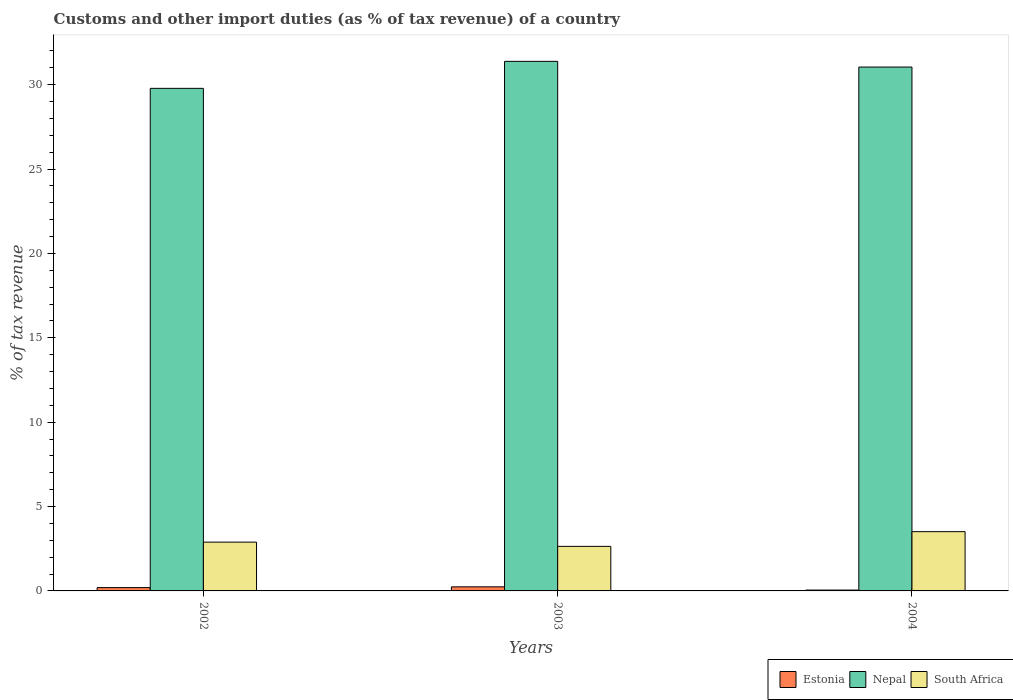How many different coloured bars are there?
Offer a very short reply. 3. How many groups of bars are there?
Offer a terse response. 3. Are the number of bars per tick equal to the number of legend labels?
Offer a terse response. Yes. How many bars are there on the 3rd tick from the left?
Your answer should be very brief. 3. How many bars are there on the 2nd tick from the right?
Keep it short and to the point. 3. What is the label of the 3rd group of bars from the left?
Provide a succinct answer. 2004. What is the percentage of tax revenue from customs in Estonia in 2003?
Make the answer very short. 0.24. Across all years, what is the maximum percentage of tax revenue from customs in Nepal?
Make the answer very short. 31.38. Across all years, what is the minimum percentage of tax revenue from customs in Nepal?
Provide a short and direct response. 29.78. In which year was the percentage of tax revenue from customs in Nepal maximum?
Your response must be concise. 2003. What is the total percentage of tax revenue from customs in Nepal in the graph?
Give a very brief answer. 92.2. What is the difference between the percentage of tax revenue from customs in Estonia in 2002 and that in 2004?
Keep it short and to the point. 0.15. What is the difference between the percentage of tax revenue from customs in Nepal in 2003 and the percentage of tax revenue from customs in Estonia in 2002?
Provide a succinct answer. 31.18. What is the average percentage of tax revenue from customs in Nepal per year?
Keep it short and to the point. 30.73. In the year 2002, what is the difference between the percentage of tax revenue from customs in Nepal and percentage of tax revenue from customs in South Africa?
Give a very brief answer. 26.89. What is the ratio of the percentage of tax revenue from customs in Nepal in 2002 to that in 2004?
Provide a succinct answer. 0.96. Is the difference between the percentage of tax revenue from customs in Nepal in 2002 and 2004 greater than the difference between the percentage of tax revenue from customs in South Africa in 2002 and 2004?
Give a very brief answer. No. What is the difference between the highest and the second highest percentage of tax revenue from customs in Estonia?
Your answer should be very brief. 0.05. What is the difference between the highest and the lowest percentage of tax revenue from customs in Nepal?
Offer a very short reply. 1.6. Is the sum of the percentage of tax revenue from customs in South Africa in 2002 and 2004 greater than the maximum percentage of tax revenue from customs in Estonia across all years?
Provide a short and direct response. Yes. What does the 3rd bar from the left in 2004 represents?
Provide a short and direct response. South Africa. What does the 1st bar from the right in 2002 represents?
Make the answer very short. South Africa. What is the difference between two consecutive major ticks on the Y-axis?
Your answer should be compact. 5. Are the values on the major ticks of Y-axis written in scientific E-notation?
Your answer should be compact. No. Does the graph contain any zero values?
Your answer should be compact. No. Where does the legend appear in the graph?
Give a very brief answer. Bottom right. How many legend labels are there?
Ensure brevity in your answer.  3. What is the title of the graph?
Provide a short and direct response. Customs and other import duties (as % of tax revenue) of a country. What is the label or title of the X-axis?
Give a very brief answer. Years. What is the label or title of the Y-axis?
Make the answer very short. % of tax revenue. What is the % of tax revenue of Estonia in 2002?
Make the answer very short. 0.2. What is the % of tax revenue of Nepal in 2002?
Give a very brief answer. 29.78. What is the % of tax revenue of South Africa in 2002?
Ensure brevity in your answer.  2.89. What is the % of tax revenue in Estonia in 2003?
Offer a terse response. 0.24. What is the % of tax revenue in Nepal in 2003?
Ensure brevity in your answer.  31.38. What is the % of tax revenue of South Africa in 2003?
Give a very brief answer. 2.64. What is the % of tax revenue of Estonia in 2004?
Offer a very short reply. 0.05. What is the % of tax revenue in Nepal in 2004?
Make the answer very short. 31.04. What is the % of tax revenue of South Africa in 2004?
Offer a very short reply. 3.51. Across all years, what is the maximum % of tax revenue in Estonia?
Offer a very short reply. 0.24. Across all years, what is the maximum % of tax revenue in Nepal?
Your response must be concise. 31.38. Across all years, what is the maximum % of tax revenue of South Africa?
Offer a terse response. 3.51. Across all years, what is the minimum % of tax revenue in Estonia?
Your answer should be compact. 0.05. Across all years, what is the minimum % of tax revenue in Nepal?
Make the answer very short. 29.78. Across all years, what is the minimum % of tax revenue of South Africa?
Keep it short and to the point. 2.64. What is the total % of tax revenue in Estonia in the graph?
Give a very brief answer. 0.49. What is the total % of tax revenue of Nepal in the graph?
Make the answer very short. 92.2. What is the total % of tax revenue in South Africa in the graph?
Give a very brief answer. 9.04. What is the difference between the % of tax revenue of Estonia in 2002 and that in 2003?
Provide a succinct answer. -0.04. What is the difference between the % of tax revenue in Nepal in 2002 and that in 2003?
Your response must be concise. -1.6. What is the difference between the % of tax revenue of South Africa in 2002 and that in 2003?
Make the answer very short. 0.25. What is the difference between the % of tax revenue in Estonia in 2002 and that in 2004?
Ensure brevity in your answer.  0.15. What is the difference between the % of tax revenue of Nepal in 2002 and that in 2004?
Give a very brief answer. -1.26. What is the difference between the % of tax revenue in South Africa in 2002 and that in 2004?
Your answer should be very brief. -0.62. What is the difference between the % of tax revenue in Estonia in 2003 and that in 2004?
Provide a short and direct response. 0.19. What is the difference between the % of tax revenue in Nepal in 2003 and that in 2004?
Offer a terse response. 0.34. What is the difference between the % of tax revenue in South Africa in 2003 and that in 2004?
Keep it short and to the point. -0.87. What is the difference between the % of tax revenue of Estonia in 2002 and the % of tax revenue of Nepal in 2003?
Your response must be concise. -31.18. What is the difference between the % of tax revenue of Estonia in 2002 and the % of tax revenue of South Africa in 2003?
Keep it short and to the point. -2.44. What is the difference between the % of tax revenue of Nepal in 2002 and the % of tax revenue of South Africa in 2003?
Ensure brevity in your answer.  27.14. What is the difference between the % of tax revenue of Estonia in 2002 and the % of tax revenue of Nepal in 2004?
Offer a very short reply. -30.85. What is the difference between the % of tax revenue of Estonia in 2002 and the % of tax revenue of South Africa in 2004?
Your response must be concise. -3.31. What is the difference between the % of tax revenue in Nepal in 2002 and the % of tax revenue in South Africa in 2004?
Provide a succinct answer. 26.27. What is the difference between the % of tax revenue in Estonia in 2003 and the % of tax revenue in Nepal in 2004?
Make the answer very short. -30.8. What is the difference between the % of tax revenue in Estonia in 2003 and the % of tax revenue in South Africa in 2004?
Your answer should be compact. -3.27. What is the difference between the % of tax revenue of Nepal in 2003 and the % of tax revenue of South Africa in 2004?
Offer a very short reply. 27.87. What is the average % of tax revenue in Estonia per year?
Give a very brief answer. 0.16. What is the average % of tax revenue in Nepal per year?
Your response must be concise. 30.73. What is the average % of tax revenue in South Africa per year?
Your response must be concise. 3.01. In the year 2002, what is the difference between the % of tax revenue in Estonia and % of tax revenue in Nepal?
Offer a terse response. -29.58. In the year 2002, what is the difference between the % of tax revenue in Estonia and % of tax revenue in South Africa?
Offer a very short reply. -2.69. In the year 2002, what is the difference between the % of tax revenue in Nepal and % of tax revenue in South Africa?
Provide a succinct answer. 26.89. In the year 2003, what is the difference between the % of tax revenue of Estonia and % of tax revenue of Nepal?
Ensure brevity in your answer.  -31.14. In the year 2003, what is the difference between the % of tax revenue in Estonia and % of tax revenue in South Africa?
Offer a terse response. -2.4. In the year 2003, what is the difference between the % of tax revenue in Nepal and % of tax revenue in South Africa?
Your response must be concise. 28.74. In the year 2004, what is the difference between the % of tax revenue in Estonia and % of tax revenue in Nepal?
Ensure brevity in your answer.  -30.99. In the year 2004, what is the difference between the % of tax revenue of Estonia and % of tax revenue of South Africa?
Ensure brevity in your answer.  -3.46. In the year 2004, what is the difference between the % of tax revenue of Nepal and % of tax revenue of South Africa?
Your answer should be compact. 27.53. What is the ratio of the % of tax revenue in Estonia in 2002 to that in 2003?
Your answer should be compact. 0.81. What is the ratio of the % of tax revenue of Nepal in 2002 to that in 2003?
Make the answer very short. 0.95. What is the ratio of the % of tax revenue in South Africa in 2002 to that in 2003?
Your answer should be very brief. 1.09. What is the ratio of the % of tax revenue of Estonia in 2002 to that in 2004?
Give a very brief answer. 3.9. What is the ratio of the % of tax revenue in Nepal in 2002 to that in 2004?
Your answer should be very brief. 0.96. What is the ratio of the % of tax revenue of South Africa in 2002 to that in 2004?
Offer a very short reply. 0.82. What is the ratio of the % of tax revenue of Estonia in 2003 to that in 2004?
Your answer should be very brief. 4.79. What is the ratio of the % of tax revenue in Nepal in 2003 to that in 2004?
Offer a very short reply. 1.01. What is the ratio of the % of tax revenue of South Africa in 2003 to that in 2004?
Your response must be concise. 0.75. What is the difference between the highest and the second highest % of tax revenue in Estonia?
Offer a very short reply. 0.04. What is the difference between the highest and the second highest % of tax revenue of Nepal?
Ensure brevity in your answer.  0.34. What is the difference between the highest and the second highest % of tax revenue of South Africa?
Provide a succinct answer. 0.62. What is the difference between the highest and the lowest % of tax revenue in Estonia?
Keep it short and to the point. 0.19. What is the difference between the highest and the lowest % of tax revenue in South Africa?
Make the answer very short. 0.87. 